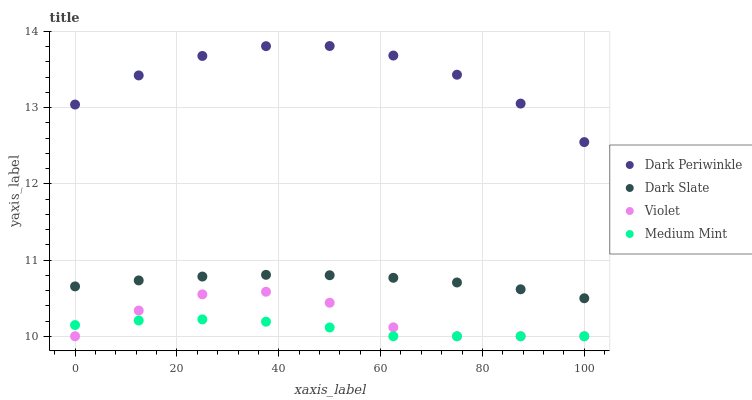Does Medium Mint have the minimum area under the curve?
Answer yes or no. Yes. Does Dark Periwinkle have the maximum area under the curve?
Answer yes or no. Yes. Does Dark Slate have the minimum area under the curve?
Answer yes or no. No. Does Dark Slate have the maximum area under the curve?
Answer yes or no. No. Is Dark Slate the smoothest?
Answer yes or no. Yes. Is Violet the roughest?
Answer yes or no. Yes. Is Dark Periwinkle the smoothest?
Answer yes or no. No. Is Dark Periwinkle the roughest?
Answer yes or no. No. Does Medium Mint have the lowest value?
Answer yes or no. Yes. Does Dark Slate have the lowest value?
Answer yes or no. No. Does Dark Periwinkle have the highest value?
Answer yes or no. Yes. Does Dark Slate have the highest value?
Answer yes or no. No. Is Medium Mint less than Dark Periwinkle?
Answer yes or no. Yes. Is Dark Slate greater than Violet?
Answer yes or no. Yes. Does Violet intersect Medium Mint?
Answer yes or no. Yes. Is Violet less than Medium Mint?
Answer yes or no. No. Is Violet greater than Medium Mint?
Answer yes or no. No. Does Medium Mint intersect Dark Periwinkle?
Answer yes or no. No. 